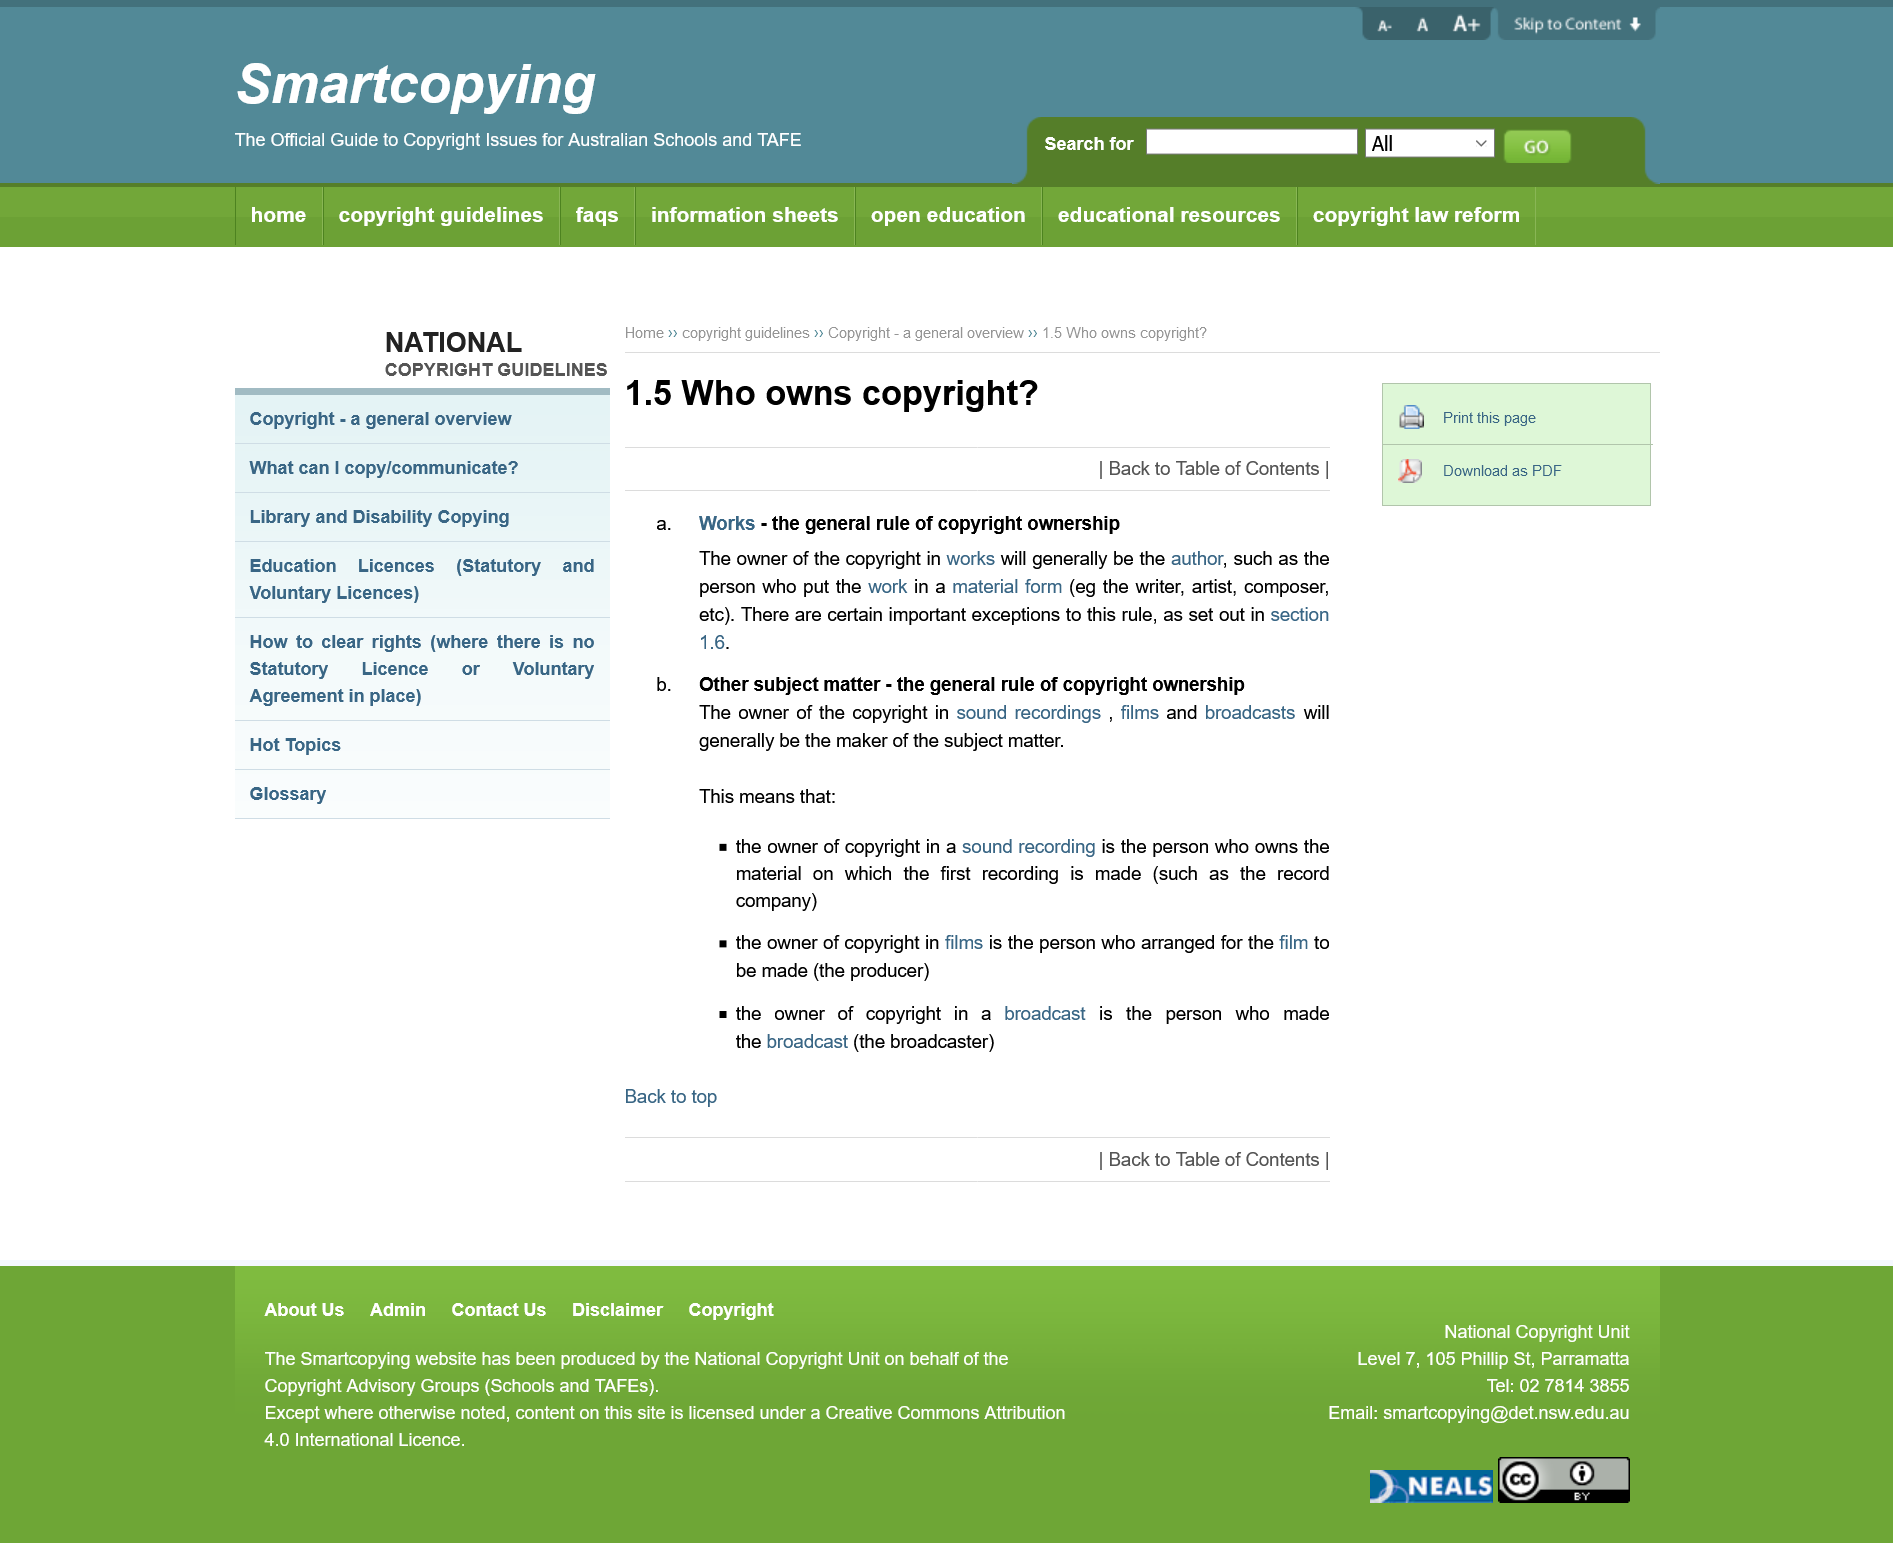Draw attention to some important aspects in this diagram. The general rule for copyright ownership is that the owner of the copyright in a work will be the author of the work. The person who put the work in a material form is the writer, artist, composer, or author. The copyright owner in sound recordings, films, and broadcasts will be considered the maker of the subject matter. 